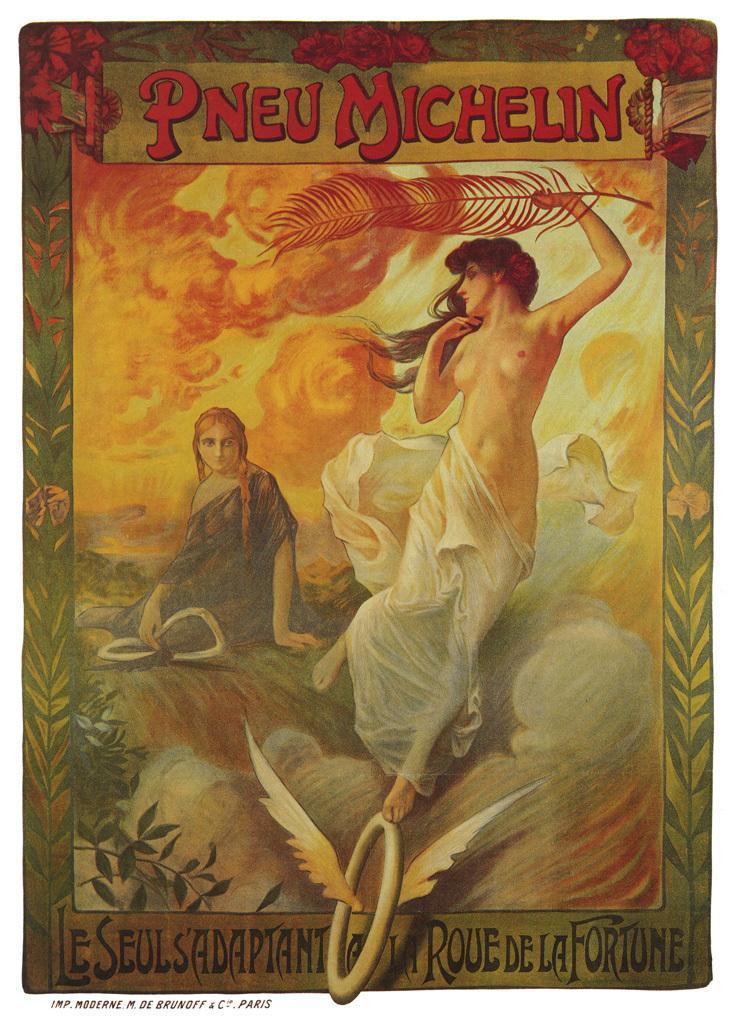In one or two sentences, can you explain what this image depicts? In this image I can see depiction of two women. I can also see something is written at few places. 